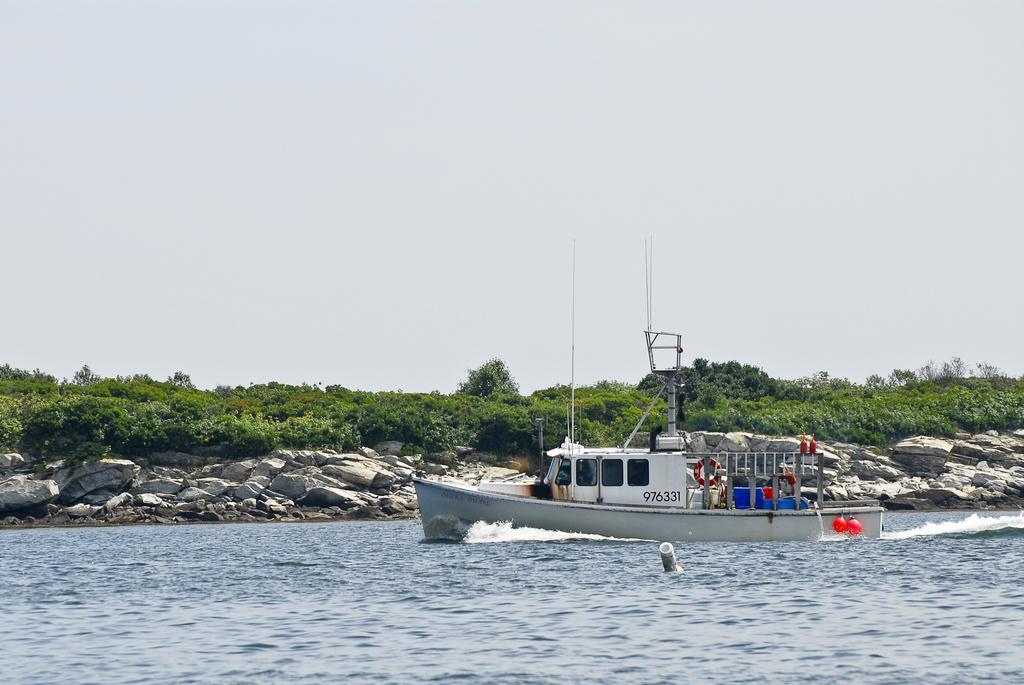What is the main subject of the image? The main subject of the image is a boat. What is the boat doing in the image? The boat is sailing on the water. What can be seen in the background of the image? There are trees and rocks in the background of the image. What is visible at the top of the image? The sky is visible at the top of the image. What type of fan is being used to cool down the water in the image? There is no fan present in the image, and the water is not being cooled down. How many quarters can be seen on the boat in the image? There are no quarters visible in the image; it only features a boat sailing on the water. 